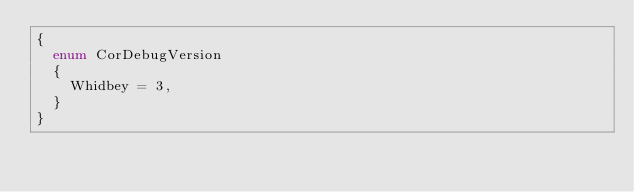<code> <loc_0><loc_0><loc_500><loc_500><_C#_>{
	enum CorDebugVersion
	{
		Whidbey = 3,
	}
}
</code> 